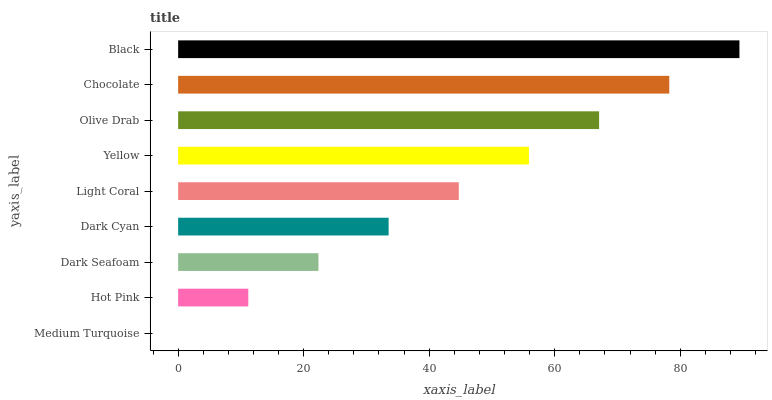Is Medium Turquoise the minimum?
Answer yes or no. Yes. Is Black the maximum?
Answer yes or no. Yes. Is Hot Pink the minimum?
Answer yes or no. No. Is Hot Pink the maximum?
Answer yes or no. No. Is Hot Pink greater than Medium Turquoise?
Answer yes or no. Yes. Is Medium Turquoise less than Hot Pink?
Answer yes or no. Yes. Is Medium Turquoise greater than Hot Pink?
Answer yes or no. No. Is Hot Pink less than Medium Turquoise?
Answer yes or no. No. Is Light Coral the high median?
Answer yes or no. Yes. Is Light Coral the low median?
Answer yes or no. Yes. Is Olive Drab the high median?
Answer yes or no. No. Is Yellow the low median?
Answer yes or no. No. 